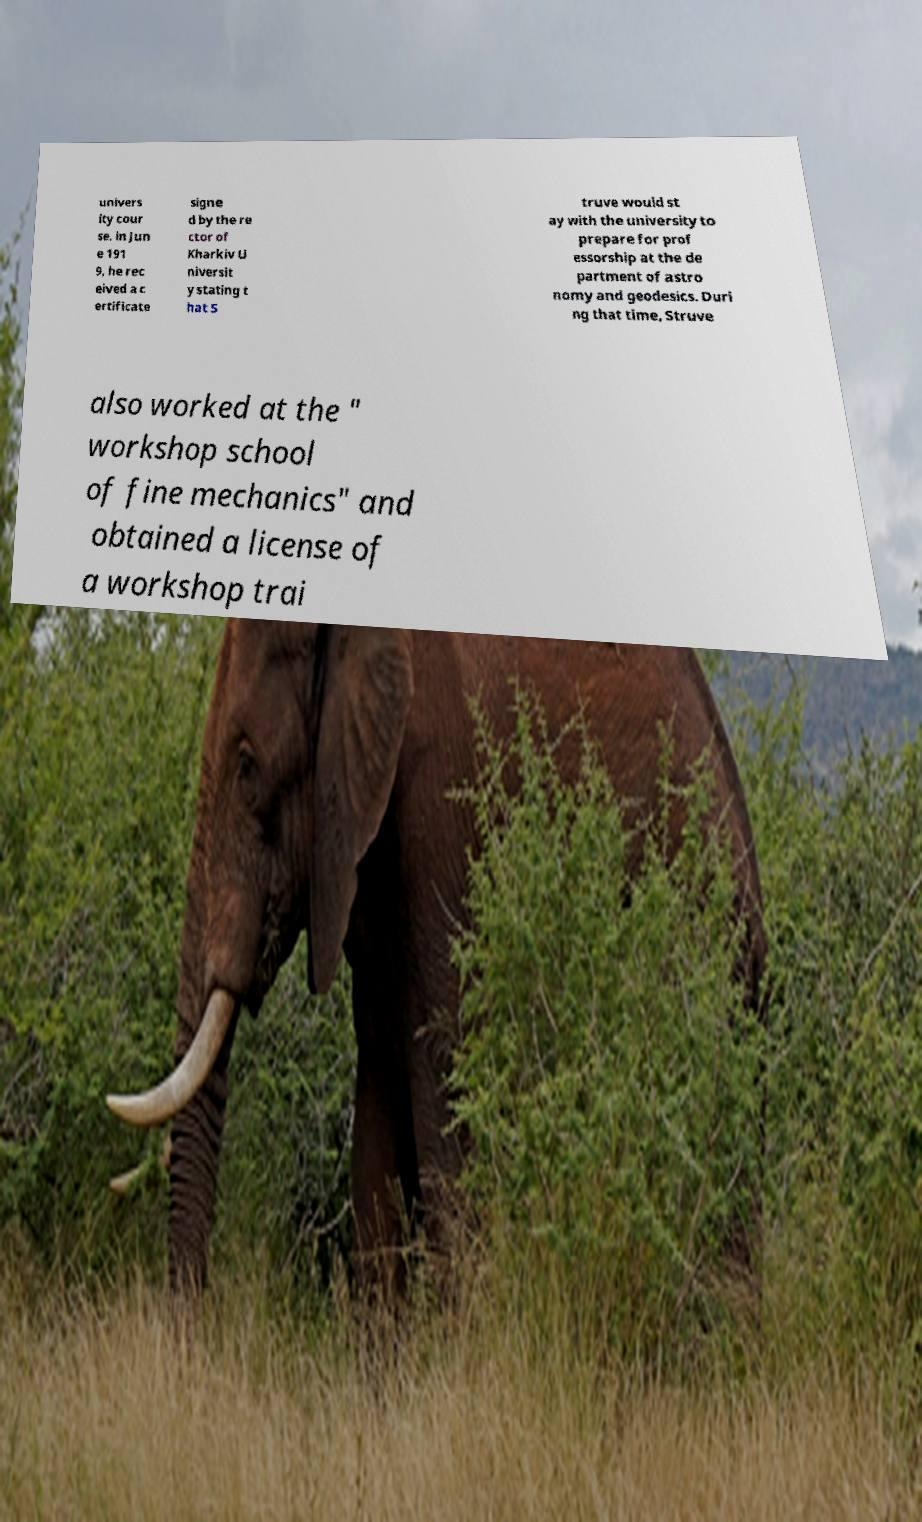There's text embedded in this image that I need extracted. Can you transcribe it verbatim? univers ity cour se. in Jun e 191 9, he rec eived a c ertificate signe d by the re ctor of Kharkiv U niversit y stating t hat S truve would st ay with the university to prepare for prof essorship at the de partment of astro nomy and geodesics. Duri ng that time, Struve also worked at the " workshop school of fine mechanics" and obtained a license of a workshop trai 